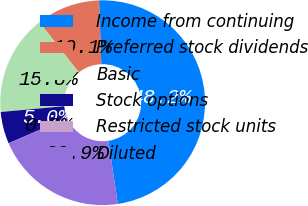Convert chart to OTSL. <chart><loc_0><loc_0><loc_500><loc_500><pie_chart><fcel>Income from continuing<fcel>Preferred stock dividends<fcel>Basic<fcel>Stock options<fcel>Restricted stock units<fcel>Diluted<nl><fcel>48.19%<fcel>10.05%<fcel>15.84%<fcel>5.04%<fcel>0.02%<fcel>20.86%<nl></chart> 